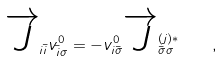Convert formula to latex. <formula><loc_0><loc_0><loc_500><loc_500>\overrightarrow { J } _ { i \bar { i } } v ^ { 0 } _ { \bar { i } \sigma } = - v ^ { 0 } _ { i \bar { \sigma } } \overrightarrow { J } ^ { ( j ) \ast } _ { \bar { \sigma } \sigma } \quad ,</formula> 